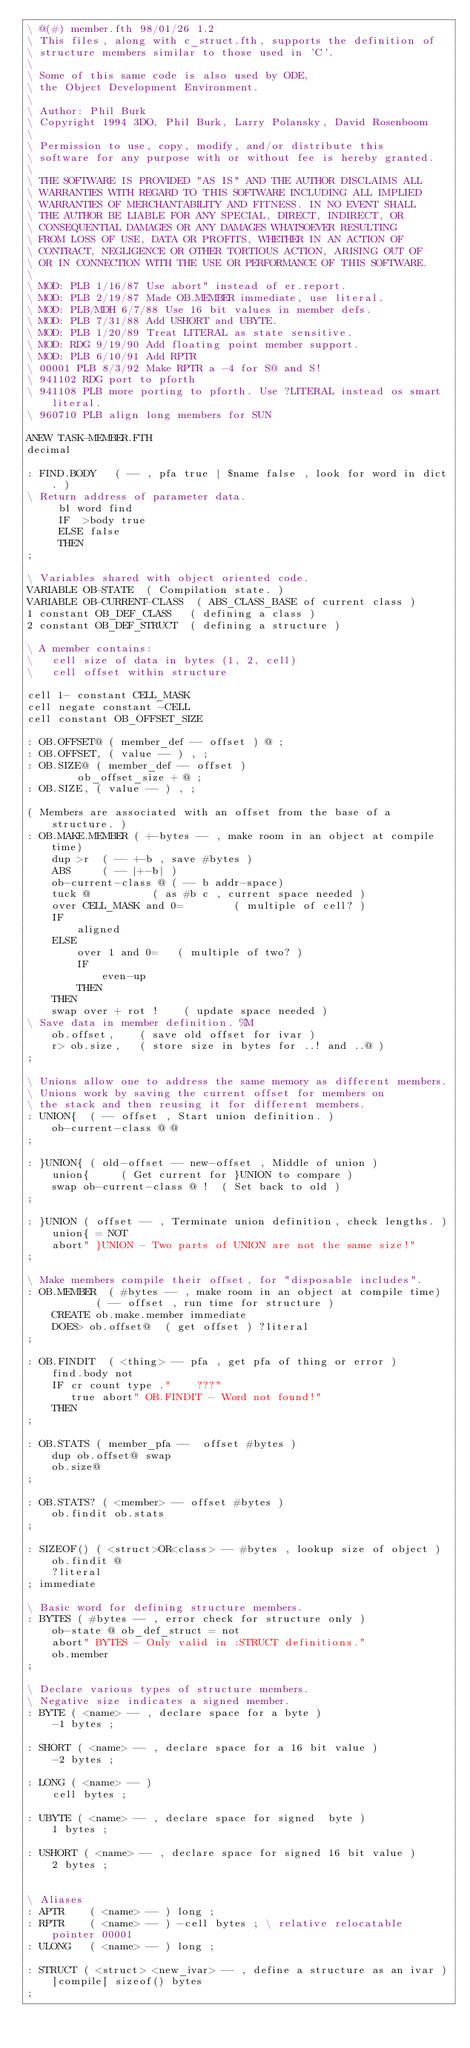<code> <loc_0><loc_0><loc_500><loc_500><_Forth_>\ @(#) member.fth 98/01/26 1.2
\ This files, along with c_struct.fth, supports the definition of
\ structure members similar to those used in 'C'.
\
\ Some of this same code is also used by ODE,
\ the Object Development Environment.
\
\ Author: Phil Burk
\ Copyright 1994 3DO, Phil Burk, Larry Polansky, David Rosenboom
\
\ Permission to use, copy, modify, and/or distribute this
\ software for any purpose with or without fee is hereby granted.
\
\ THE SOFTWARE IS PROVIDED "AS IS" AND THE AUTHOR DISCLAIMS ALL
\ WARRANTIES WITH REGARD TO THIS SOFTWARE INCLUDING ALL IMPLIED
\ WARRANTIES OF MERCHANTABILITY AND FITNESS. IN NO EVENT SHALL
\ THE AUTHOR BE LIABLE FOR ANY SPECIAL, DIRECT, INDIRECT, OR
\ CONSEQUENTIAL DAMAGES OR ANY DAMAGES WHATSOEVER RESULTING
\ FROM LOSS OF USE, DATA OR PROFITS, WHETHER IN AN ACTION OF
\ CONTRACT, NEGLIGENCE OR OTHER TORTIOUS ACTION, ARISING OUT OF
\ OR IN CONNECTION WITH THE USE OR PERFORMANCE OF THIS SOFTWARE.
\
\ MOD: PLB 1/16/87 Use abort" instead of er.report.
\ MOD: PLB 2/19/87 Made OB.MEMBER immediate, use literal.
\ MOD: PLB/MDH 6/7/88 Use 16 bit values in member defs.
\ MOD: PLB 7/31/88 Add USHORT and UBYTE.
\ MOD: PLB 1/20/89 Treat LITERAL as state sensitive.
\ MOD: RDG 9/19/90 Add floating point member support.
\ MOD: PLB 6/10/91 Add RPTR
\ 00001 PLB 8/3/92 Make RPTR a -4 for S@ and S!
\ 941102 RDG port to pforth
\ 941108 PLB more porting to pforth. Use ?LITERAL instead os smart literal.
\ 960710 PLB align long members for SUN

ANEW TASK-MEMBER.FTH
decimal

: FIND.BODY   ( -- , pfa true | $name false , look for word in dict. )
\ Return address of parameter data.
     bl word find
     IF  >body true
     ELSE false
     THEN
;

\ Variables shared with object oriented code.
VARIABLE OB-STATE  ( Compilation state. )
VARIABLE OB-CURRENT-CLASS  ( ABS_CLASS_BASE of current class )
1 constant OB_DEF_CLASS   ( defining a class )
2 constant OB_DEF_STRUCT  ( defining a structure )

\ A member contains:
\   cell size of data in bytes (1, 2, cell)
\   cell offset within structure

cell 1- constant CELL_MASK
cell negate constant -CELL
cell constant OB_OFFSET_SIZE

: OB.OFFSET@ ( member_def -- offset ) @ ;
: OB.OFFSET, ( value -- ) , ;
: OB.SIZE@ ( member_def -- offset )
        ob_offset_size + @ ;
: OB.SIZE, ( value -- ) , ;

( Members are associated with an offset from the base of a structure. )
: OB.MAKE.MEMBER ( +-bytes -- , make room in an object at compile time)
    dup >r  ( -- +-b , save #bytes )
    ABS     ( -- |+-b| )
    ob-current-class @ ( -- b addr-space)
    tuck @          ( as #b c , current space needed )
    over CELL_MASK and 0=        ( multiple of cell? )
    IF
        aligned
    ELSE
        over 1 and 0=   ( multiple of two? )
        IF
            even-up
        THEN
    THEN
    swap over + rot !    ( update space needed )
\ Save data in member definition. %M
    ob.offset,    ( save old offset for ivar )
    r> ob.size,   ( store size in bytes for ..! and ..@ )
;

\ Unions allow one to address the same memory as different members.
\ Unions work by saving the current offset for members on
\ the stack and then reusing it for different members.
: UNION{  ( -- offset , Start union definition. )
    ob-current-class @ @
;

: }UNION{ ( old-offset -- new-offset , Middle of union )
    union{     ( Get current for }UNION to compare )
    swap ob-current-class @ !  ( Set back to old )
;

: }UNION ( offset -- , Terminate union definition, check lengths. )
    union{ = NOT
    abort" }UNION - Two parts of UNION are not the same size!"
;

\ Make members compile their offset, for "disposable includes".
: OB.MEMBER  ( #bytes -- , make room in an object at compile time)
           ( -- offset , run time for structure )
    CREATE ob.make.member immediate
    DOES> ob.offset@  ( get offset ) ?literal
;

: OB.FINDIT  ( <thing> -- pfa , get pfa of thing or error )
    find.body not
    IF cr count type ."    ???"
       true abort" OB.FINDIT - Word not found!"
    THEN
;

: OB.STATS ( member_pfa --  offset #bytes )
    dup ob.offset@ swap
    ob.size@
;

: OB.STATS? ( <member> -- offset #bytes )
    ob.findit ob.stats
;

: SIZEOF() ( <struct>OR<class> -- #bytes , lookup size of object )
    ob.findit @
    ?literal
; immediate

\ Basic word for defining structure members.
: BYTES ( #bytes -- , error check for structure only )
    ob-state @ ob_def_struct = not
    abort" BYTES - Only valid in :STRUCT definitions."
    ob.member
;

\ Declare various types of structure members.
\ Negative size indicates a signed member.
: BYTE ( <name> -- , declare space for a byte )
    -1 bytes ;

: SHORT ( <name> -- , declare space for a 16 bit value )
    -2 bytes ;

: LONG ( <name> -- )
    cell bytes ;

: UBYTE ( <name> -- , declare space for signed  byte )
    1 bytes ;

: USHORT ( <name> -- , declare space for signed 16 bit value )
    2 bytes ;


\ Aliases
: APTR    ( <name> -- ) long ;
: RPTR    ( <name> -- ) -cell bytes ; \ relative relocatable pointer 00001
: ULONG   ( <name> -- ) long ;

: STRUCT ( <struct> <new_ivar> -- , define a structure as an ivar )
    [compile] sizeof() bytes
;
</code> 